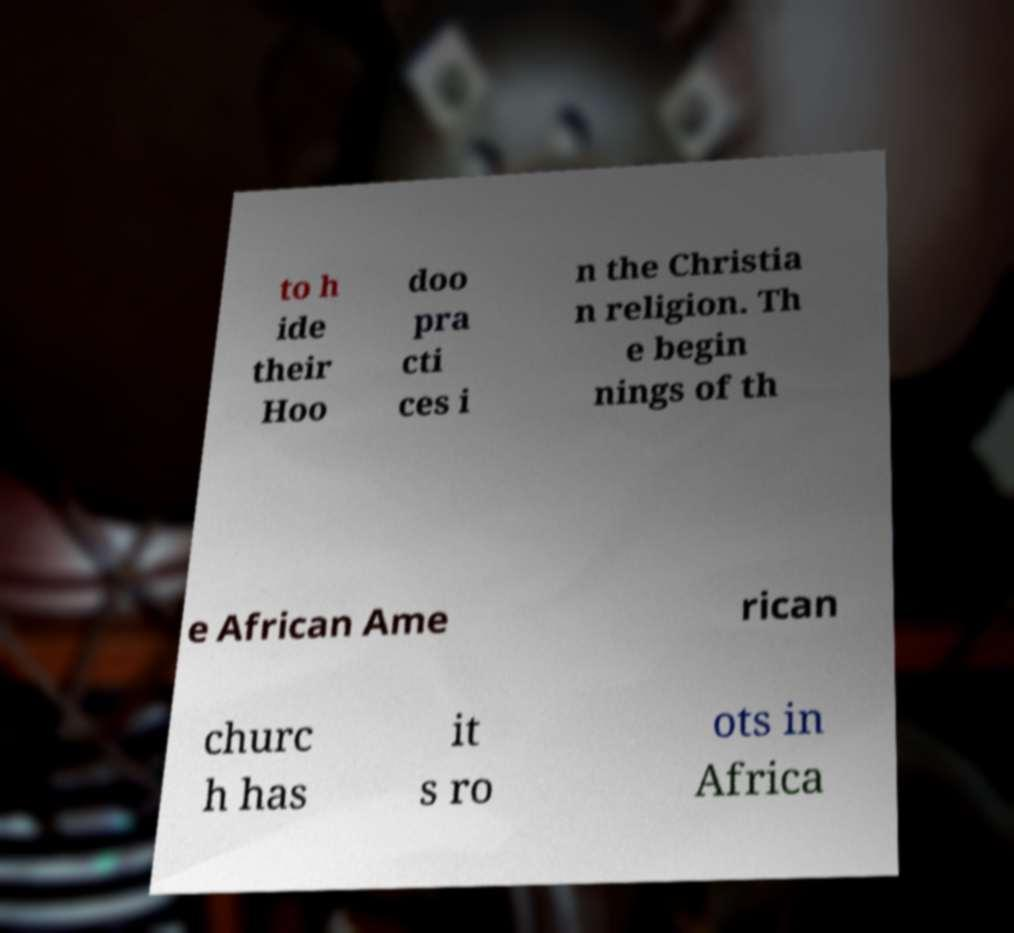There's text embedded in this image that I need extracted. Can you transcribe it verbatim? to h ide their Hoo doo pra cti ces i n the Christia n religion. Th e begin nings of th e African Ame rican churc h has it s ro ots in Africa 